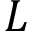Convert formula to latex. <formula><loc_0><loc_0><loc_500><loc_500>L</formula> 